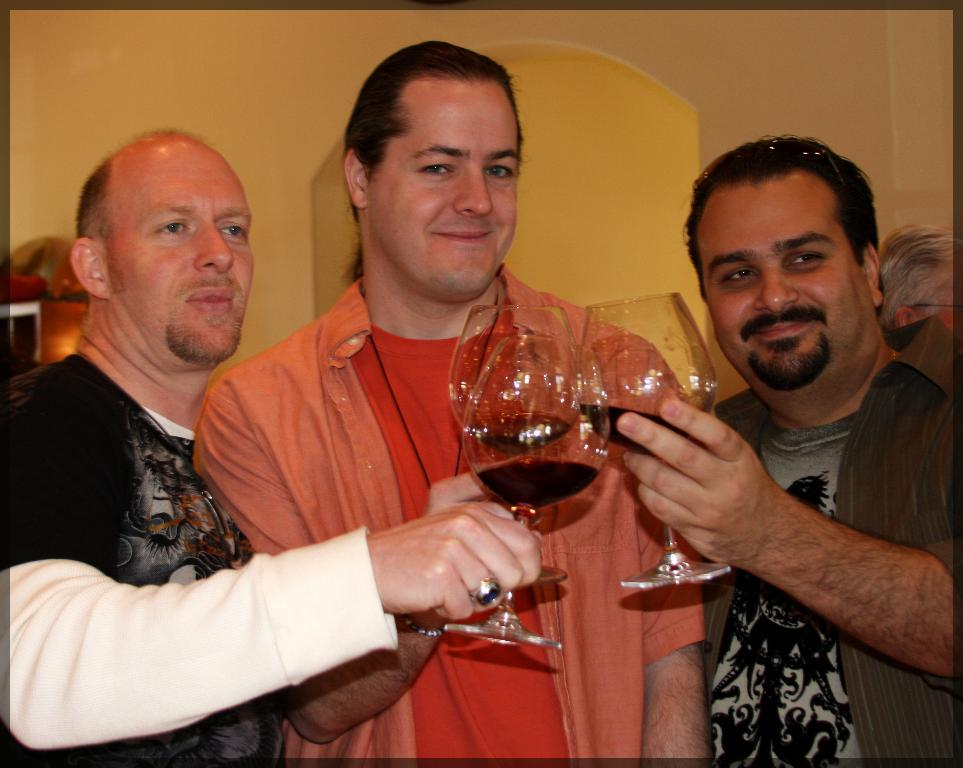How many people are in the foreground of the picture? There are three people standing in the foreground of the picture. What are the people holding in their hands? The people are holding glasses. What can be seen in the background of the image? There is a wall in the background of the image. What type of rose is being used as a decoration at the party in the image? There is no party or rose present in the image; it features three people holding glasses in the foreground and a wall in the background. 